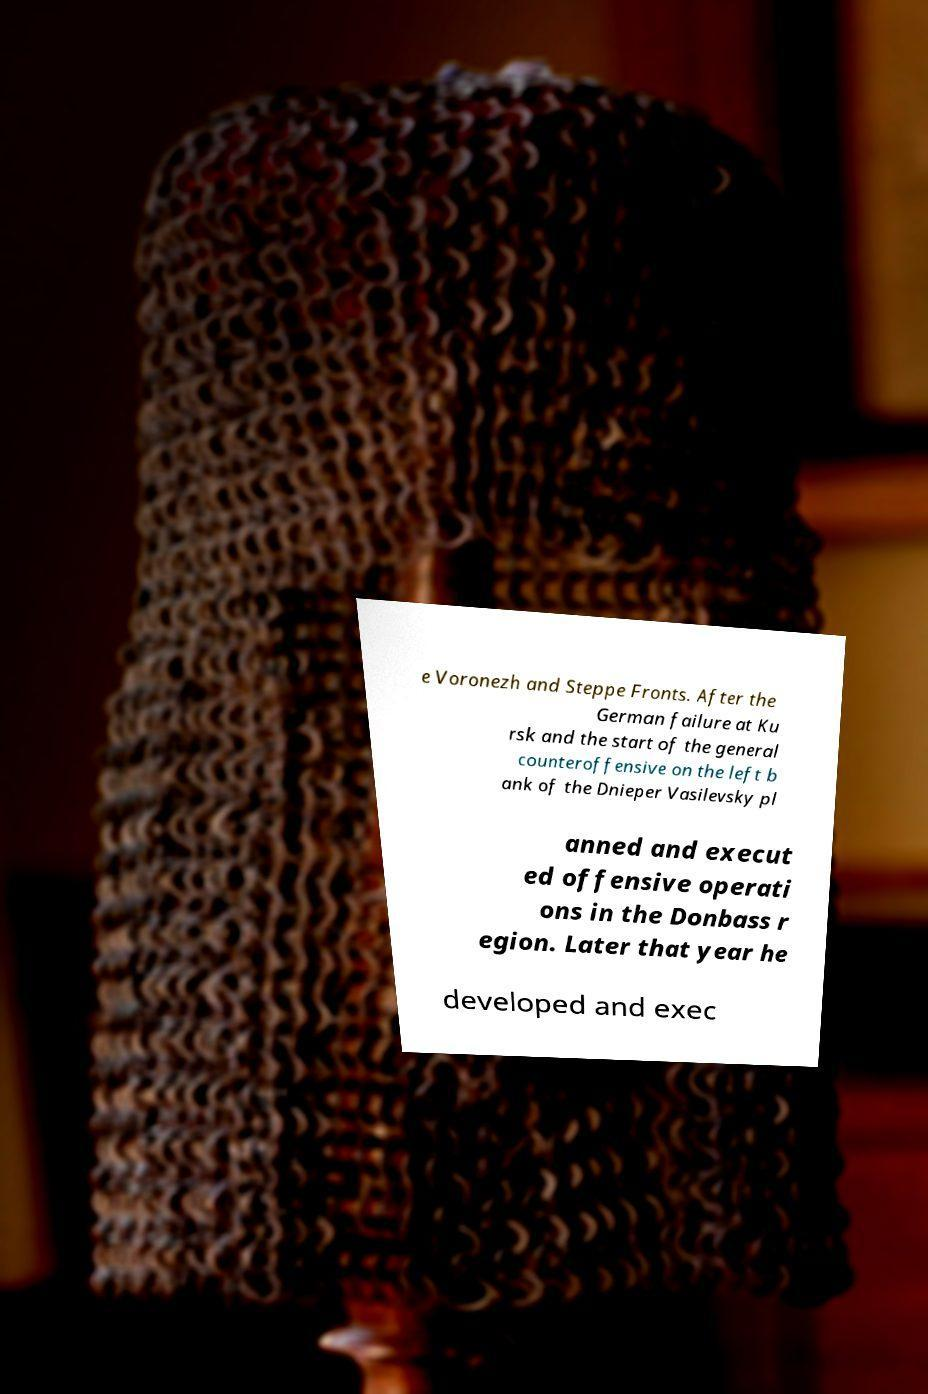I need the written content from this picture converted into text. Can you do that? e Voronezh and Steppe Fronts. After the German failure at Ku rsk and the start of the general counteroffensive on the left b ank of the Dnieper Vasilevsky pl anned and execut ed offensive operati ons in the Donbass r egion. Later that year he developed and exec 